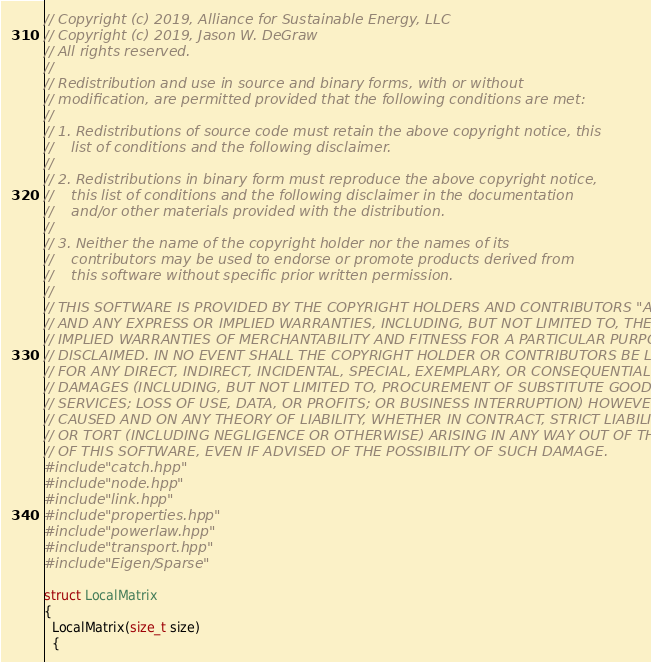<code> <loc_0><loc_0><loc_500><loc_500><_C++_>// Copyright (c) 2019, Alliance for Sustainable Energy, LLC
// Copyright (c) 2019, Jason W. DeGraw
// All rights reserved.
//
// Redistribution and use in source and binary forms, with or without
// modification, are permitted provided that the following conditions are met:
//
// 1. Redistributions of source code must retain the above copyright notice, this
//    list of conditions and the following disclaimer.
//
// 2. Redistributions in binary form must reproduce the above copyright notice,
//    this list of conditions and the following disclaimer in the documentation
//    and/or other materials provided with the distribution.
//
// 3. Neither the name of the copyright holder nor the names of its
//    contributors may be used to endorse or promote products derived from
//    this software without specific prior written permission.
//
// THIS SOFTWARE IS PROVIDED BY THE COPYRIGHT HOLDERS AND CONTRIBUTORS "AS IS"
// AND ANY EXPRESS OR IMPLIED WARRANTIES, INCLUDING, BUT NOT LIMITED TO, THE
// IMPLIED WARRANTIES OF MERCHANTABILITY AND FITNESS FOR A PARTICULAR PURPOSE ARE
// DISCLAIMED. IN NO EVENT SHALL THE COPYRIGHT HOLDER OR CONTRIBUTORS BE LIABLE
// FOR ANY DIRECT, INDIRECT, INCIDENTAL, SPECIAL, EXEMPLARY, OR CONSEQUENTIAL
// DAMAGES (INCLUDING, BUT NOT LIMITED TO, PROCUREMENT OF SUBSTITUTE GOODS OR
// SERVICES; LOSS OF USE, DATA, OR PROFITS; OR BUSINESS INTERRUPTION) HOWEVER
// CAUSED AND ON ANY THEORY OF LIABILITY, WHETHER IN CONTRACT, STRICT LIABILITY,
// OR TORT (INCLUDING NEGLIGENCE OR OTHERWISE) ARISING IN ANY WAY OUT OF THE USE
// OF THIS SOFTWARE, EVEN IF ADVISED OF THE POSSIBILITY OF SUCH DAMAGE.
#include "catch.hpp"
#include "node.hpp"
#include "link.hpp"
#include "properties.hpp"
#include "powerlaw.hpp"
#include "transport.hpp"
#include "Eigen/Sparse"

struct LocalMatrix
{
  LocalMatrix(size_t size)
  {</code> 